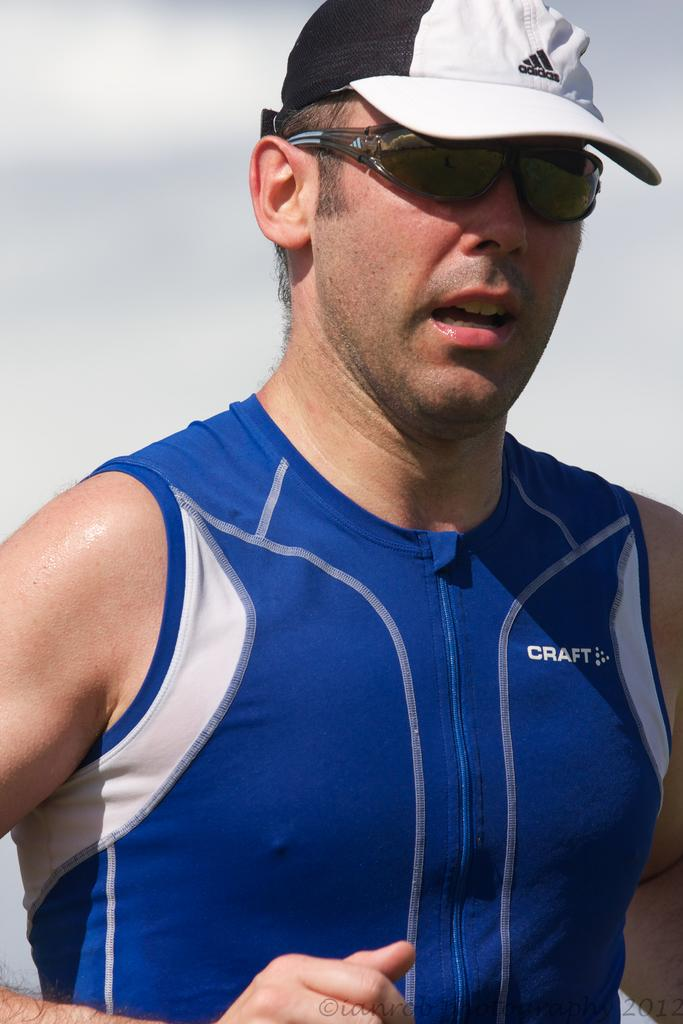What is the main subject in the foreground of the image? There is a man in the foreground of the image. What is the man wearing on his upper body? The man is wearing a blue T-shirt. What type of headwear is the man wearing? The man is wearing a white and black cap. What accessory is the man wearing on his face? The man is wearing spectacles. How would you describe the background of the image? The background of the image is blurred. What type of ear is visible on the man in the image? There is no specific ear mentioned or visible in the image; we can only see the man's head and cap. 